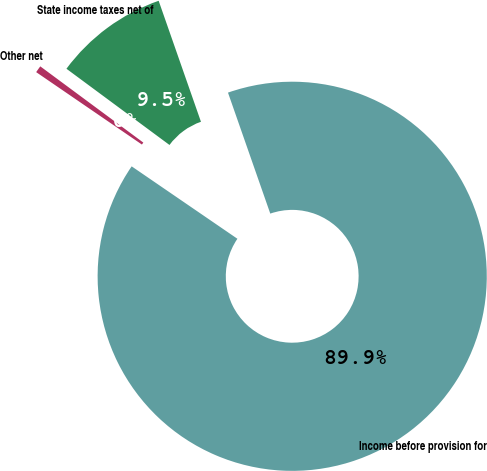<chart> <loc_0><loc_0><loc_500><loc_500><pie_chart><fcel>Income before provision for<fcel>State income taxes net of<fcel>Other net<nl><fcel>89.91%<fcel>9.51%<fcel>0.58%<nl></chart> 